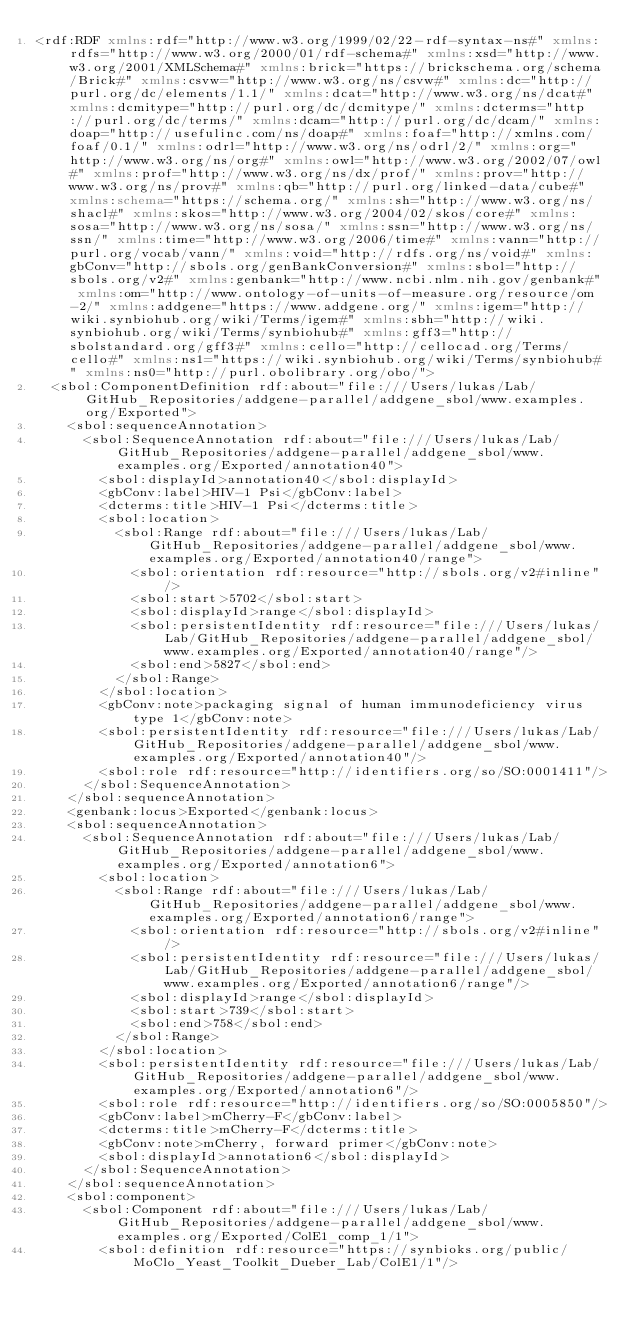<code> <loc_0><loc_0><loc_500><loc_500><_XML_><rdf:RDF xmlns:rdf="http://www.w3.org/1999/02/22-rdf-syntax-ns#" xmlns:rdfs="http://www.w3.org/2000/01/rdf-schema#" xmlns:xsd="http://www.w3.org/2001/XMLSchema#" xmlns:brick="https://brickschema.org/schema/Brick#" xmlns:csvw="http://www.w3.org/ns/csvw#" xmlns:dc="http://purl.org/dc/elements/1.1/" xmlns:dcat="http://www.w3.org/ns/dcat#" xmlns:dcmitype="http://purl.org/dc/dcmitype/" xmlns:dcterms="http://purl.org/dc/terms/" xmlns:dcam="http://purl.org/dc/dcam/" xmlns:doap="http://usefulinc.com/ns/doap#" xmlns:foaf="http://xmlns.com/foaf/0.1/" xmlns:odrl="http://www.w3.org/ns/odrl/2/" xmlns:org="http://www.w3.org/ns/org#" xmlns:owl="http://www.w3.org/2002/07/owl#" xmlns:prof="http://www.w3.org/ns/dx/prof/" xmlns:prov="http://www.w3.org/ns/prov#" xmlns:qb="http://purl.org/linked-data/cube#" xmlns:schema="https://schema.org/" xmlns:sh="http://www.w3.org/ns/shacl#" xmlns:skos="http://www.w3.org/2004/02/skos/core#" xmlns:sosa="http://www.w3.org/ns/sosa/" xmlns:ssn="http://www.w3.org/ns/ssn/" xmlns:time="http://www.w3.org/2006/time#" xmlns:vann="http://purl.org/vocab/vann/" xmlns:void="http://rdfs.org/ns/void#" xmlns:gbConv="http://sbols.org/genBankConversion#" xmlns:sbol="http://sbols.org/v2#" xmlns:genbank="http://www.ncbi.nlm.nih.gov/genbank#" xmlns:om="http://www.ontology-of-units-of-measure.org/resource/om-2/" xmlns:addgene="https://www.addgene.org/" xmlns:igem="http://wiki.synbiohub.org/wiki/Terms/igem#" xmlns:sbh="http://wiki.synbiohub.org/wiki/Terms/synbiohub#" xmlns:gff3="http://sbolstandard.org/gff3#" xmlns:cello="http://cellocad.org/Terms/cello#" xmlns:ns1="https://wiki.synbiohub.org/wiki/Terms/synbiohub#" xmlns:ns0="http://purl.obolibrary.org/obo/">
  <sbol:ComponentDefinition rdf:about="file:///Users/lukas/Lab/GitHub_Repositories/addgene-parallel/addgene_sbol/www.examples.org/Exported">
    <sbol:sequenceAnnotation>
      <sbol:SequenceAnnotation rdf:about="file:///Users/lukas/Lab/GitHub_Repositories/addgene-parallel/addgene_sbol/www.examples.org/Exported/annotation40">
        <sbol:displayId>annotation40</sbol:displayId>
        <gbConv:label>HIV-1 Psi</gbConv:label>
        <dcterms:title>HIV-1 Psi</dcterms:title>
        <sbol:location>
          <sbol:Range rdf:about="file:///Users/lukas/Lab/GitHub_Repositories/addgene-parallel/addgene_sbol/www.examples.org/Exported/annotation40/range">
            <sbol:orientation rdf:resource="http://sbols.org/v2#inline"/>
            <sbol:start>5702</sbol:start>
            <sbol:displayId>range</sbol:displayId>
            <sbol:persistentIdentity rdf:resource="file:///Users/lukas/Lab/GitHub_Repositories/addgene-parallel/addgene_sbol/www.examples.org/Exported/annotation40/range"/>
            <sbol:end>5827</sbol:end>
          </sbol:Range>
        </sbol:location>
        <gbConv:note>packaging signal of human immunodeficiency virus type 1</gbConv:note>
        <sbol:persistentIdentity rdf:resource="file:///Users/lukas/Lab/GitHub_Repositories/addgene-parallel/addgene_sbol/www.examples.org/Exported/annotation40"/>
        <sbol:role rdf:resource="http://identifiers.org/so/SO:0001411"/>
      </sbol:SequenceAnnotation>
    </sbol:sequenceAnnotation>
    <genbank:locus>Exported</genbank:locus>
    <sbol:sequenceAnnotation>
      <sbol:SequenceAnnotation rdf:about="file:///Users/lukas/Lab/GitHub_Repositories/addgene-parallel/addgene_sbol/www.examples.org/Exported/annotation6">
        <sbol:location>
          <sbol:Range rdf:about="file:///Users/lukas/Lab/GitHub_Repositories/addgene-parallel/addgene_sbol/www.examples.org/Exported/annotation6/range">
            <sbol:orientation rdf:resource="http://sbols.org/v2#inline"/>
            <sbol:persistentIdentity rdf:resource="file:///Users/lukas/Lab/GitHub_Repositories/addgene-parallel/addgene_sbol/www.examples.org/Exported/annotation6/range"/>
            <sbol:displayId>range</sbol:displayId>
            <sbol:start>739</sbol:start>
            <sbol:end>758</sbol:end>
          </sbol:Range>
        </sbol:location>
        <sbol:persistentIdentity rdf:resource="file:///Users/lukas/Lab/GitHub_Repositories/addgene-parallel/addgene_sbol/www.examples.org/Exported/annotation6"/>
        <sbol:role rdf:resource="http://identifiers.org/so/SO:0005850"/>
        <gbConv:label>mCherry-F</gbConv:label>
        <dcterms:title>mCherry-F</dcterms:title>
        <gbConv:note>mCherry, forward primer</gbConv:note>
        <sbol:displayId>annotation6</sbol:displayId>
      </sbol:SequenceAnnotation>
    </sbol:sequenceAnnotation>
    <sbol:component>
      <sbol:Component rdf:about="file:///Users/lukas/Lab/GitHub_Repositories/addgene-parallel/addgene_sbol/www.examples.org/Exported/ColE1_comp_1/1">
        <sbol:definition rdf:resource="https://synbioks.org/public/MoClo_Yeast_Toolkit_Dueber_Lab/ColE1/1"/></code> 